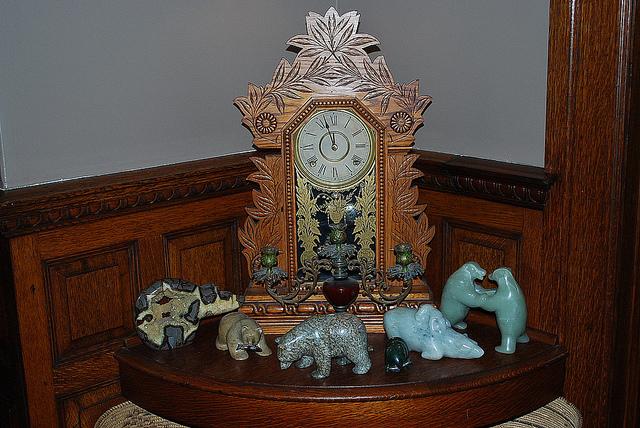What is the background made of?
Answer briefly. Wood. What's the bird atop the clock?
Keep it brief. No. What animal are the knick knacks?
Answer briefly. Bears. Is this a grandfather clock?
Keep it brief. No. How many items are pictured in front of the clock?
Answer briefly. 6. 